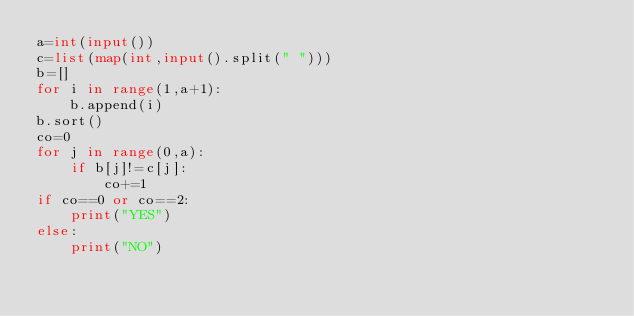Convert code to text. <code><loc_0><loc_0><loc_500><loc_500><_Python_>a=int(input())
c=list(map(int,input().split(" ")))
b=[]
for i in range(1,a+1):
    b.append(i)
b.sort()
co=0
for j in range(0,a):
    if b[j]!=c[j]:
        co+=1
if co==0 or co==2:
    print("YES")
else:
    print("NO")</code> 